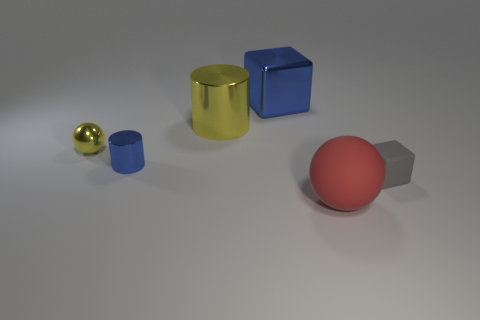What shape is the yellow metal thing that is the same size as the red matte thing? The yellow metal object is a cylinder. It shares the same cylindrical shape and size as the red matte object to its right, both resembling the form of a standard soda can. 